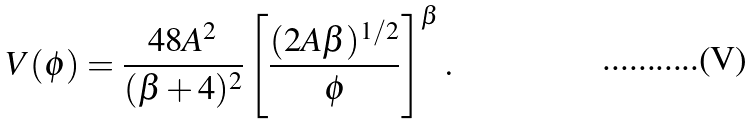Convert formula to latex. <formula><loc_0><loc_0><loc_500><loc_500>V ( \phi ) = \frac { 4 8 A ^ { 2 } } { ( \beta + 4 ) ^ { 2 } } \left [ \frac { ( 2 A \beta ) ^ { 1 / 2 } } { \phi } \right ] ^ { \beta } .</formula> 